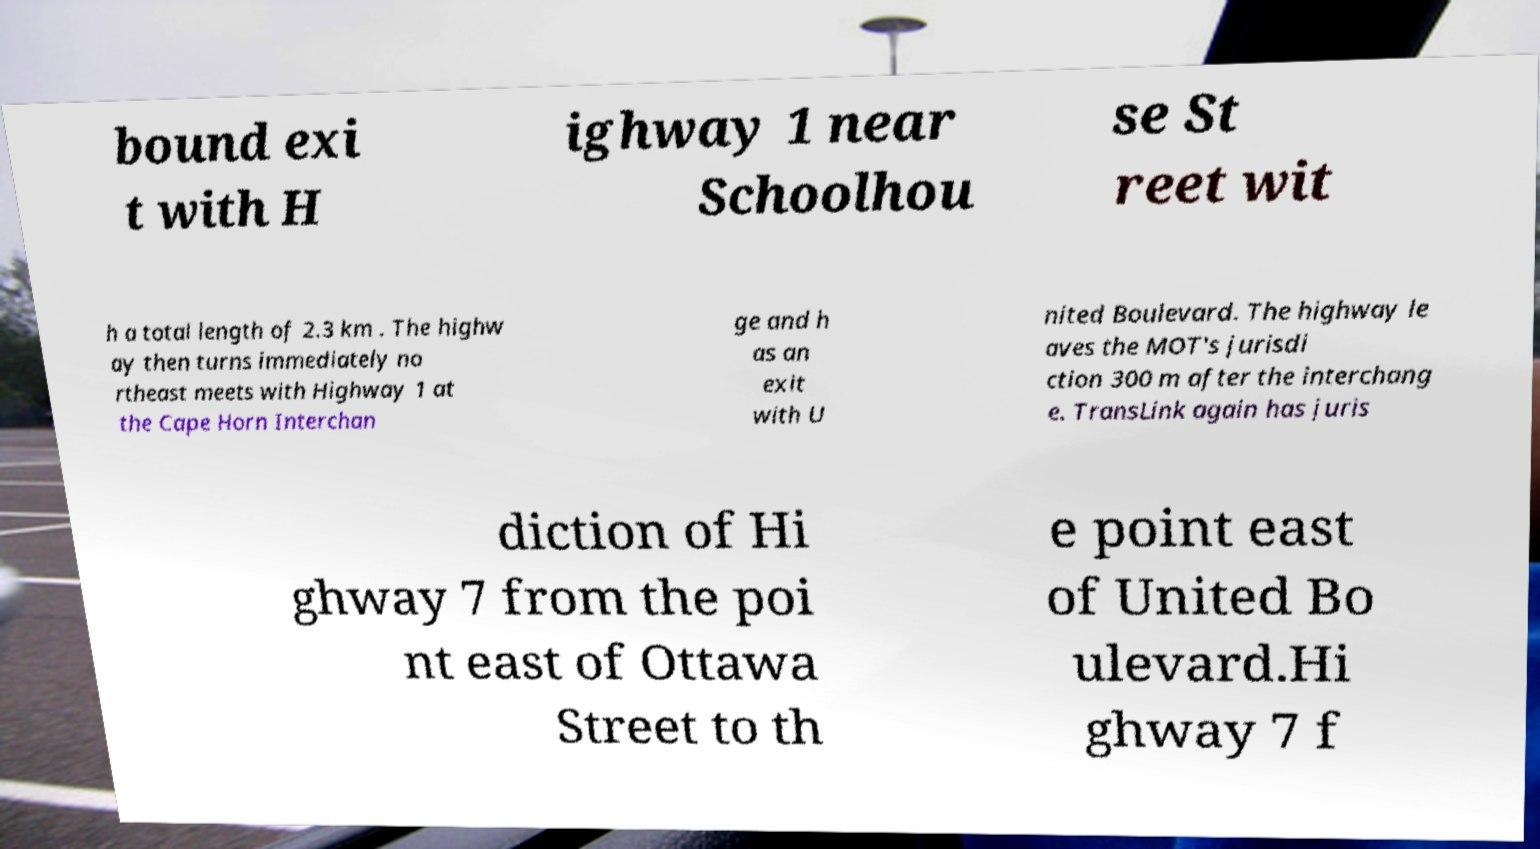Could you assist in decoding the text presented in this image and type it out clearly? bound exi t with H ighway 1 near Schoolhou se St reet wit h a total length of 2.3 km . The highw ay then turns immediately no rtheast meets with Highway 1 at the Cape Horn Interchan ge and h as an exit with U nited Boulevard. The highway le aves the MOT's jurisdi ction 300 m after the interchang e. TransLink again has juris diction of Hi ghway 7 from the poi nt east of Ottawa Street to th e point east of United Bo ulevard.Hi ghway 7 f 